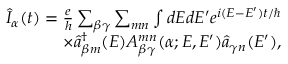<formula> <loc_0><loc_0><loc_500><loc_500>\begin{array} { r } { \hat { I } _ { \alpha } ( t ) = \frac { e } { h } \sum _ { \beta \gamma } \sum _ { m n } \int d E d E ^ { \prime } e ^ { i ( E - E ^ { \prime } ) t / } } \\ { \times \hat { a } _ { \beta m } ^ { \dagger } ( E ) A _ { \beta \gamma } ^ { m n } ( \alpha ; E , E ^ { \prime } ) \hat { a } _ { \gamma n } ( E ^ { \prime } ) , } \end{array}</formula> 